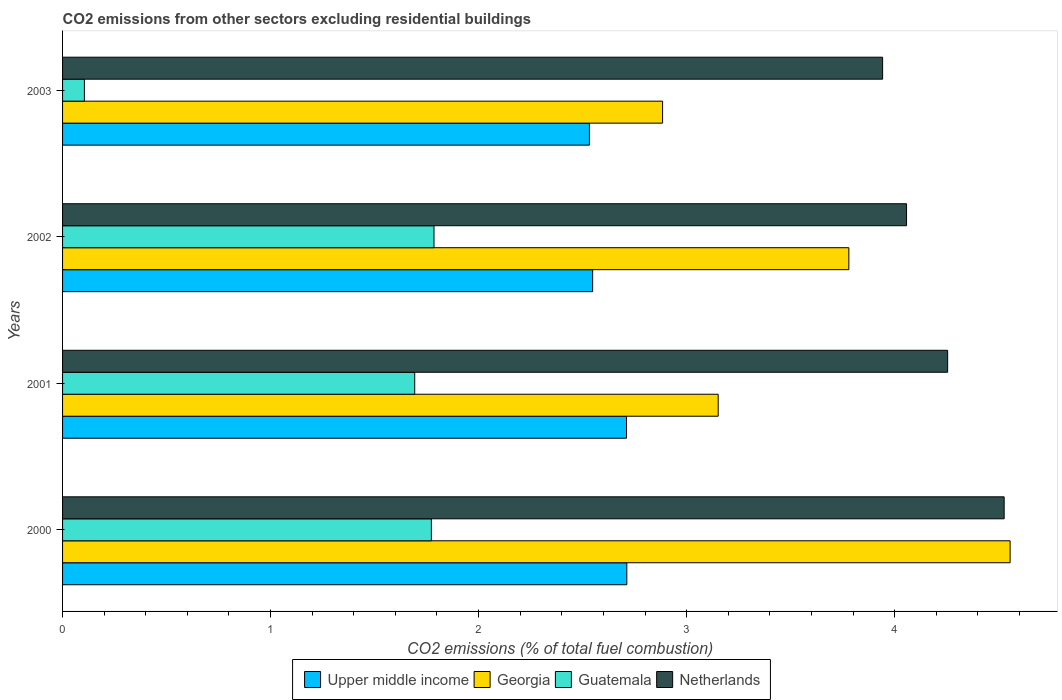How many different coloured bars are there?
Provide a short and direct response. 4. How many bars are there on the 1st tick from the top?
Your answer should be compact. 4. How many bars are there on the 1st tick from the bottom?
Offer a very short reply. 4. In how many cases, is the number of bars for a given year not equal to the number of legend labels?
Provide a short and direct response. 0. What is the total CO2 emitted in Netherlands in 2002?
Make the answer very short. 4.06. Across all years, what is the maximum total CO2 emitted in Upper middle income?
Your answer should be very brief. 2.71. Across all years, what is the minimum total CO2 emitted in Georgia?
Provide a short and direct response. 2.88. In which year was the total CO2 emitted in Netherlands maximum?
Your answer should be compact. 2000. What is the total total CO2 emitted in Georgia in the graph?
Provide a short and direct response. 14.37. What is the difference between the total CO2 emitted in Guatemala in 2000 and that in 2001?
Offer a very short reply. 0.08. What is the difference between the total CO2 emitted in Guatemala in 2000 and the total CO2 emitted in Upper middle income in 2003?
Provide a succinct answer. -0.76. What is the average total CO2 emitted in Georgia per year?
Your answer should be very brief. 3.59. In the year 2003, what is the difference between the total CO2 emitted in Upper middle income and total CO2 emitted in Netherlands?
Give a very brief answer. -1.41. What is the ratio of the total CO2 emitted in Upper middle income in 2001 to that in 2002?
Your answer should be compact. 1.06. Is the difference between the total CO2 emitted in Upper middle income in 2000 and 2003 greater than the difference between the total CO2 emitted in Netherlands in 2000 and 2003?
Your answer should be compact. No. What is the difference between the highest and the second highest total CO2 emitted in Netherlands?
Your answer should be very brief. 0.27. What is the difference between the highest and the lowest total CO2 emitted in Netherlands?
Provide a short and direct response. 0.58. Is the sum of the total CO2 emitted in Netherlands in 2001 and 2002 greater than the maximum total CO2 emitted in Guatemala across all years?
Ensure brevity in your answer.  Yes. What does the 2nd bar from the top in 2002 represents?
Your answer should be very brief. Guatemala. What does the 1st bar from the bottom in 2002 represents?
Give a very brief answer. Upper middle income. Are all the bars in the graph horizontal?
Keep it short and to the point. Yes. What is the difference between two consecutive major ticks on the X-axis?
Provide a succinct answer. 1. Does the graph contain grids?
Keep it short and to the point. No. How many legend labels are there?
Offer a very short reply. 4. What is the title of the graph?
Your answer should be compact. CO2 emissions from other sectors excluding residential buildings. What is the label or title of the X-axis?
Provide a short and direct response. CO2 emissions (% of total fuel combustion). What is the label or title of the Y-axis?
Make the answer very short. Years. What is the CO2 emissions (% of total fuel combustion) in Upper middle income in 2000?
Provide a succinct answer. 2.71. What is the CO2 emissions (% of total fuel combustion) of Georgia in 2000?
Offer a very short reply. 4.56. What is the CO2 emissions (% of total fuel combustion) in Guatemala in 2000?
Provide a short and direct response. 1.77. What is the CO2 emissions (% of total fuel combustion) in Netherlands in 2000?
Your response must be concise. 4.53. What is the CO2 emissions (% of total fuel combustion) in Upper middle income in 2001?
Provide a succinct answer. 2.71. What is the CO2 emissions (% of total fuel combustion) of Georgia in 2001?
Your answer should be compact. 3.15. What is the CO2 emissions (% of total fuel combustion) in Guatemala in 2001?
Make the answer very short. 1.69. What is the CO2 emissions (% of total fuel combustion) of Netherlands in 2001?
Your answer should be very brief. 4.25. What is the CO2 emissions (% of total fuel combustion) in Upper middle income in 2002?
Your response must be concise. 2.55. What is the CO2 emissions (% of total fuel combustion) of Georgia in 2002?
Your answer should be compact. 3.78. What is the CO2 emissions (% of total fuel combustion) in Guatemala in 2002?
Make the answer very short. 1.79. What is the CO2 emissions (% of total fuel combustion) of Netherlands in 2002?
Make the answer very short. 4.06. What is the CO2 emissions (% of total fuel combustion) of Upper middle income in 2003?
Your response must be concise. 2.53. What is the CO2 emissions (% of total fuel combustion) of Georgia in 2003?
Offer a terse response. 2.88. What is the CO2 emissions (% of total fuel combustion) in Guatemala in 2003?
Provide a short and direct response. 0.1. What is the CO2 emissions (% of total fuel combustion) in Netherlands in 2003?
Provide a succinct answer. 3.94. Across all years, what is the maximum CO2 emissions (% of total fuel combustion) of Upper middle income?
Offer a terse response. 2.71. Across all years, what is the maximum CO2 emissions (% of total fuel combustion) of Georgia?
Give a very brief answer. 4.56. Across all years, what is the maximum CO2 emissions (% of total fuel combustion) in Guatemala?
Your response must be concise. 1.79. Across all years, what is the maximum CO2 emissions (% of total fuel combustion) of Netherlands?
Give a very brief answer. 4.53. Across all years, what is the minimum CO2 emissions (% of total fuel combustion) of Upper middle income?
Keep it short and to the point. 2.53. Across all years, what is the minimum CO2 emissions (% of total fuel combustion) in Georgia?
Make the answer very short. 2.88. Across all years, what is the minimum CO2 emissions (% of total fuel combustion) in Guatemala?
Offer a terse response. 0.1. Across all years, what is the minimum CO2 emissions (% of total fuel combustion) of Netherlands?
Give a very brief answer. 3.94. What is the total CO2 emissions (% of total fuel combustion) of Upper middle income in the graph?
Ensure brevity in your answer.  10.51. What is the total CO2 emissions (% of total fuel combustion) of Georgia in the graph?
Provide a short and direct response. 14.37. What is the total CO2 emissions (% of total fuel combustion) in Guatemala in the graph?
Keep it short and to the point. 5.36. What is the total CO2 emissions (% of total fuel combustion) in Netherlands in the graph?
Your answer should be compact. 16.78. What is the difference between the CO2 emissions (% of total fuel combustion) in Upper middle income in 2000 and that in 2001?
Your response must be concise. 0. What is the difference between the CO2 emissions (% of total fuel combustion) in Georgia in 2000 and that in 2001?
Provide a short and direct response. 1.4. What is the difference between the CO2 emissions (% of total fuel combustion) in Netherlands in 2000 and that in 2001?
Give a very brief answer. 0.27. What is the difference between the CO2 emissions (% of total fuel combustion) in Upper middle income in 2000 and that in 2002?
Your answer should be compact. 0.16. What is the difference between the CO2 emissions (% of total fuel combustion) in Georgia in 2000 and that in 2002?
Keep it short and to the point. 0.78. What is the difference between the CO2 emissions (% of total fuel combustion) in Guatemala in 2000 and that in 2002?
Ensure brevity in your answer.  -0.01. What is the difference between the CO2 emissions (% of total fuel combustion) of Netherlands in 2000 and that in 2002?
Keep it short and to the point. 0.47. What is the difference between the CO2 emissions (% of total fuel combustion) in Upper middle income in 2000 and that in 2003?
Your answer should be compact. 0.18. What is the difference between the CO2 emissions (% of total fuel combustion) of Georgia in 2000 and that in 2003?
Keep it short and to the point. 1.67. What is the difference between the CO2 emissions (% of total fuel combustion) in Guatemala in 2000 and that in 2003?
Give a very brief answer. 1.67. What is the difference between the CO2 emissions (% of total fuel combustion) of Netherlands in 2000 and that in 2003?
Keep it short and to the point. 0.58. What is the difference between the CO2 emissions (% of total fuel combustion) in Upper middle income in 2001 and that in 2002?
Keep it short and to the point. 0.16. What is the difference between the CO2 emissions (% of total fuel combustion) of Georgia in 2001 and that in 2002?
Offer a very short reply. -0.63. What is the difference between the CO2 emissions (% of total fuel combustion) in Guatemala in 2001 and that in 2002?
Give a very brief answer. -0.09. What is the difference between the CO2 emissions (% of total fuel combustion) of Netherlands in 2001 and that in 2002?
Offer a terse response. 0.2. What is the difference between the CO2 emissions (% of total fuel combustion) in Upper middle income in 2001 and that in 2003?
Give a very brief answer. 0.18. What is the difference between the CO2 emissions (% of total fuel combustion) of Georgia in 2001 and that in 2003?
Your answer should be compact. 0.27. What is the difference between the CO2 emissions (% of total fuel combustion) of Guatemala in 2001 and that in 2003?
Your answer should be very brief. 1.59. What is the difference between the CO2 emissions (% of total fuel combustion) in Netherlands in 2001 and that in 2003?
Provide a succinct answer. 0.31. What is the difference between the CO2 emissions (% of total fuel combustion) in Upper middle income in 2002 and that in 2003?
Provide a short and direct response. 0.02. What is the difference between the CO2 emissions (% of total fuel combustion) in Georgia in 2002 and that in 2003?
Your response must be concise. 0.9. What is the difference between the CO2 emissions (% of total fuel combustion) in Guatemala in 2002 and that in 2003?
Your response must be concise. 1.68. What is the difference between the CO2 emissions (% of total fuel combustion) in Netherlands in 2002 and that in 2003?
Offer a very short reply. 0.12. What is the difference between the CO2 emissions (% of total fuel combustion) in Upper middle income in 2000 and the CO2 emissions (% of total fuel combustion) in Georgia in 2001?
Provide a succinct answer. -0.44. What is the difference between the CO2 emissions (% of total fuel combustion) of Upper middle income in 2000 and the CO2 emissions (% of total fuel combustion) of Guatemala in 2001?
Keep it short and to the point. 1.02. What is the difference between the CO2 emissions (% of total fuel combustion) of Upper middle income in 2000 and the CO2 emissions (% of total fuel combustion) of Netherlands in 2001?
Make the answer very short. -1.54. What is the difference between the CO2 emissions (% of total fuel combustion) of Georgia in 2000 and the CO2 emissions (% of total fuel combustion) of Guatemala in 2001?
Offer a very short reply. 2.86. What is the difference between the CO2 emissions (% of total fuel combustion) of Georgia in 2000 and the CO2 emissions (% of total fuel combustion) of Netherlands in 2001?
Make the answer very short. 0.3. What is the difference between the CO2 emissions (% of total fuel combustion) in Guatemala in 2000 and the CO2 emissions (% of total fuel combustion) in Netherlands in 2001?
Your answer should be very brief. -2.48. What is the difference between the CO2 emissions (% of total fuel combustion) of Upper middle income in 2000 and the CO2 emissions (% of total fuel combustion) of Georgia in 2002?
Offer a very short reply. -1.07. What is the difference between the CO2 emissions (% of total fuel combustion) of Upper middle income in 2000 and the CO2 emissions (% of total fuel combustion) of Guatemala in 2002?
Keep it short and to the point. 0.93. What is the difference between the CO2 emissions (% of total fuel combustion) of Upper middle income in 2000 and the CO2 emissions (% of total fuel combustion) of Netherlands in 2002?
Provide a short and direct response. -1.34. What is the difference between the CO2 emissions (% of total fuel combustion) of Georgia in 2000 and the CO2 emissions (% of total fuel combustion) of Guatemala in 2002?
Give a very brief answer. 2.77. What is the difference between the CO2 emissions (% of total fuel combustion) in Georgia in 2000 and the CO2 emissions (% of total fuel combustion) in Netherlands in 2002?
Your answer should be compact. 0.5. What is the difference between the CO2 emissions (% of total fuel combustion) of Guatemala in 2000 and the CO2 emissions (% of total fuel combustion) of Netherlands in 2002?
Provide a succinct answer. -2.28. What is the difference between the CO2 emissions (% of total fuel combustion) in Upper middle income in 2000 and the CO2 emissions (% of total fuel combustion) in Georgia in 2003?
Provide a short and direct response. -0.17. What is the difference between the CO2 emissions (% of total fuel combustion) of Upper middle income in 2000 and the CO2 emissions (% of total fuel combustion) of Guatemala in 2003?
Your response must be concise. 2.61. What is the difference between the CO2 emissions (% of total fuel combustion) in Upper middle income in 2000 and the CO2 emissions (% of total fuel combustion) in Netherlands in 2003?
Your answer should be very brief. -1.23. What is the difference between the CO2 emissions (% of total fuel combustion) of Georgia in 2000 and the CO2 emissions (% of total fuel combustion) of Guatemala in 2003?
Provide a succinct answer. 4.45. What is the difference between the CO2 emissions (% of total fuel combustion) of Georgia in 2000 and the CO2 emissions (% of total fuel combustion) of Netherlands in 2003?
Your response must be concise. 0.61. What is the difference between the CO2 emissions (% of total fuel combustion) in Guatemala in 2000 and the CO2 emissions (% of total fuel combustion) in Netherlands in 2003?
Your response must be concise. -2.17. What is the difference between the CO2 emissions (% of total fuel combustion) in Upper middle income in 2001 and the CO2 emissions (% of total fuel combustion) in Georgia in 2002?
Your answer should be compact. -1.07. What is the difference between the CO2 emissions (% of total fuel combustion) in Upper middle income in 2001 and the CO2 emissions (% of total fuel combustion) in Guatemala in 2002?
Offer a very short reply. 0.93. What is the difference between the CO2 emissions (% of total fuel combustion) of Upper middle income in 2001 and the CO2 emissions (% of total fuel combustion) of Netherlands in 2002?
Offer a very short reply. -1.35. What is the difference between the CO2 emissions (% of total fuel combustion) of Georgia in 2001 and the CO2 emissions (% of total fuel combustion) of Guatemala in 2002?
Offer a very short reply. 1.37. What is the difference between the CO2 emissions (% of total fuel combustion) of Georgia in 2001 and the CO2 emissions (% of total fuel combustion) of Netherlands in 2002?
Make the answer very short. -0.91. What is the difference between the CO2 emissions (% of total fuel combustion) in Guatemala in 2001 and the CO2 emissions (% of total fuel combustion) in Netherlands in 2002?
Make the answer very short. -2.36. What is the difference between the CO2 emissions (% of total fuel combustion) of Upper middle income in 2001 and the CO2 emissions (% of total fuel combustion) of Georgia in 2003?
Your answer should be compact. -0.17. What is the difference between the CO2 emissions (% of total fuel combustion) of Upper middle income in 2001 and the CO2 emissions (% of total fuel combustion) of Guatemala in 2003?
Provide a succinct answer. 2.61. What is the difference between the CO2 emissions (% of total fuel combustion) in Upper middle income in 2001 and the CO2 emissions (% of total fuel combustion) in Netherlands in 2003?
Ensure brevity in your answer.  -1.23. What is the difference between the CO2 emissions (% of total fuel combustion) in Georgia in 2001 and the CO2 emissions (% of total fuel combustion) in Guatemala in 2003?
Your response must be concise. 3.05. What is the difference between the CO2 emissions (% of total fuel combustion) of Georgia in 2001 and the CO2 emissions (% of total fuel combustion) of Netherlands in 2003?
Offer a very short reply. -0.79. What is the difference between the CO2 emissions (% of total fuel combustion) in Guatemala in 2001 and the CO2 emissions (% of total fuel combustion) in Netherlands in 2003?
Keep it short and to the point. -2.25. What is the difference between the CO2 emissions (% of total fuel combustion) in Upper middle income in 2002 and the CO2 emissions (% of total fuel combustion) in Georgia in 2003?
Offer a very short reply. -0.34. What is the difference between the CO2 emissions (% of total fuel combustion) in Upper middle income in 2002 and the CO2 emissions (% of total fuel combustion) in Guatemala in 2003?
Make the answer very short. 2.44. What is the difference between the CO2 emissions (% of total fuel combustion) of Upper middle income in 2002 and the CO2 emissions (% of total fuel combustion) of Netherlands in 2003?
Your response must be concise. -1.39. What is the difference between the CO2 emissions (% of total fuel combustion) in Georgia in 2002 and the CO2 emissions (% of total fuel combustion) in Guatemala in 2003?
Offer a terse response. 3.68. What is the difference between the CO2 emissions (% of total fuel combustion) of Georgia in 2002 and the CO2 emissions (% of total fuel combustion) of Netherlands in 2003?
Offer a very short reply. -0.16. What is the difference between the CO2 emissions (% of total fuel combustion) in Guatemala in 2002 and the CO2 emissions (% of total fuel combustion) in Netherlands in 2003?
Provide a short and direct response. -2.16. What is the average CO2 emissions (% of total fuel combustion) of Upper middle income per year?
Provide a succinct answer. 2.63. What is the average CO2 emissions (% of total fuel combustion) in Georgia per year?
Offer a very short reply. 3.59. What is the average CO2 emissions (% of total fuel combustion) of Guatemala per year?
Your answer should be compact. 1.34. What is the average CO2 emissions (% of total fuel combustion) of Netherlands per year?
Ensure brevity in your answer.  4.2. In the year 2000, what is the difference between the CO2 emissions (% of total fuel combustion) in Upper middle income and CO2 emissions (% of total fuel combustion) in Georgia?
Provide a short and direct response. -1.84. In the year 2000, what is the difference between the CO2 emissions (% of total fuel combustion) in Upper middle income and CO2 emissions (% of total fuel combustion) in Guatemala?
Ensure brevity in your answer.  0.94. In the year 2000, what is the difference between the CO2 emissions (% of total fuel combustion) of Upper middle income and CO2 emissions (% of total fuel combustion) of Netherlands?
Make the answer very short. -1.81. In the year 2000, what is the difference between the CO2 emissions (% of total fuel combustion) of Georgia and CO2 emissions (% of total fuel combustion) of Guatemala?
Ensure brevity in your answer.  2.78. In the year 2000, what is the difference between the CO2 emissions (% of total fuel combustion) of Georgia and CO2 emissions (% of total fuel combustion) of Netherlands?
Give a very brief answer. 0.03. In the year 2000, what is the difference between the CO2 emissions (% of total fuel combustion) in Guatemala and CO2 emissions (% of total fuel combustion) in Netherlands?
Provide a succinct answer. -2.75. In the year 2001, what is the difference between the CO2 emissions (% of total fuel combustion) of Upper middle income and CO2 emissions (% of total fuel combustion) of Georgia?
Offer a terse response. -0.44. In the year 2001, what is the difference between the CO2 emissions (% of total fuel combustion) of Upper middle income and CO2 emissions (% of total fuel combustion) of Guatemala?
Give a very brief answer. 1.02. In the year 2001, what is the difference between the CO2 emissions (% of total fuel combustion) in Upper middle income and CO2 emissions (% of total fuel combustion) in Netherlands?
Give a very brief answer. -1.54. In the year 2001, what is the difference between the CO2 emissions (% of total fuel combustion) of Georgia and CO2 emissions (% of total fuel combustion) of Guatemala?
Your answer should be compact. 1.46. In the year 2001, what is the difference between the CO2 emissions (% of total fuel combustion) in Georgia and CO2 emissions (% of total fuel combustion) in Netherlands?
Make the answer very short. -1.1. In the year 2001, what is the difference between the CO2 emissions (% of total fuel combustion) of Guatemala and CO2 emissions (% of total fuel combustion) of Netherlands?
Provide a succinct answer. -2.56. In the year 2002, what is the difference between the CO2 emissions (% of total fuel combustion) of Upper middle income and CO2 emissions (% of total fuel combustion) of Georgia?
Your answer should be very brief. -1.23. In the year 2002, what is the difference between the CO2 emissions (% of total fuel combustion) of Upper middle income and CO2 emissions (% of total fuel combustion) of Guatemala?
Make the answer very short. 0.76. In the year 2002, what is the difference between the CO2 emissions (% of total fuel combustion) in Upper middle income and CO2 emissions (% of total fuel combustion) in Netherlands?
Ensure brevity in your answer.  -1.51. In the year 2002, what is the difference between the CO2 emissions (% of total fuel combustion) in Georgia and CO2 emissions (% of total fuel combustion) in Guatemala?
Ensure brevity in your answer.  1.99. In the year 2002, what is the difference between the CO2 emissions (% of total fuel combustion) of Georgia and CO2 emissions (% of total fuel combustion) of Netherlands?
Give a very brief answer. -0.28. In the year 2002, what is the difference between the CO2 emissions (% of total fuel combustion) in Guatemala and CO2 emissions (% of total fuel combustion) in Netherlands?
Provide a succinct answer. -2.27. In the year 2003, what is the difference between the CO2 emissions (% of total fuel combustion) in Upper middle income and CO2 emissions (% of total fuel combustion) in Georgia?
Your response must be concise. -0.35. In the year 2003, what is the difference between the CO2 emissions (% of total fuel combustion) in Upper middle income and CO2 emissions (% of total fuel combustion) in Guatemala?
Provide a short and direct response. 2.43. In the year 2003, what is the difference between the CO2 emissions (% of total fuel combustion) of Upper middle income and CO2 emissions (% of total fuel combustion) of Netherlands?
Your answer should be very brief. -1.41. In the year 2003, what is the difference between the CO2 emissions (% of total fuel combustion) of Georgia and CO2 emissions (% of total fuel combustion) of Guatemala?
Your answer should be very brief. 2.78. In the year 2003, what is the difference between the CO2 emissions (% of total fuel combustion) in Georgia and CO2 emissions (% of total fuel combustion) in Netherlands?
Your answer should be compact. -1.06. In the year 2003, what is the difference between the CO2 emissions (% of total fuel combustion) of Guatemala and CO2 emissions (% of total fuel combustion) of Netherlands?
Keep it short and to the point. -3.84. What is the ratio of the CO2 emissions (% of total fuel combustion) of Georgia in 2000 to that in 2001?
Your answer should be very brief. 1.45. What is the ratio of the CO2 emissions (% of total fuel combustion) in Guatemala in 2000 to that in 2001?
Offer a terse response. 1.05. What is the ratio of the CO2 emissions (% of total fuel combustion) of Netherlands in 2000 to that in 2001?
Offer a very short reply. 1.06. What is the ratio of the CO2 emissions (% of total fuel combustion) in Upper middle income in 2000 to that in 2002?
Your answer should be compact. 1.06. What is the ratio of the CO2 emissions (% of total fuel combustion) in Georgia in 2000 to that in 2002?
Make the answer very short. 1.21. What is the ratio of the CO2 emissions (% of total fuel combustion) in Guatemala in 2000 to that in 2002?
Provide a succinct answer. 0.99. What is the ratio of the CO2 emissions (% of total fuel combustion) in Netherlands in 2000 to that in 2002?
Provide a short and direct response. 1.12. What is the ratio of the CO2 emissions (% of total fuel combustion) in Upper middle income in 2000 to that in 2003?
Keep it short and to the point. 1.07. What is the ratio of the CO2 emissions (% of total fuel combustion) in Georgia in 2000 to that in 2003?
Offer a terse response. 1.58. What is the ratio of the CO2 emissions (% of total fuel combustion) in Guatemala in 2000 to that in 2003?
Ensure brevity in your answer.  16.9. What is the ratio of the CO2 emissions (% of total fuel combustion) of Netherlands in 2000 to that in 2003?
Provide a succinct answer. 1.15. What is the ratio of the CO2 emissions (% of total fuel combustion) of Upper middle income in 2001 to that in 2002?
Provide a succinct answer. 1.06. What is the ratio of the CO2 emissions (% of total fuel combustion) in Georgia in 2001 to that in 2002?
Offer a very short reply. 0.83. What is the ratio of the CO2 emissions (% of total fuel combustion) in Guatemala in 2001 to that in 2002?
Ensure brevity in your answer.  0.95. What is the ratio of the CO2 emissions (% of total fuel combustion) of Netherlands in 2001 to that in 2002?
Give a very brief answer. 1.05. What is the ratio of the CO2 emissions (% of total fuel combustion) in Upper middle income in 2001 to that in 2003?
Keep it short and to the point. 1.07. What is the ratio of the CO2 emissions (% of total fuel combustion) of Georgia in 2001 to that in 2003?
Provide a succinct answer. 1.09. What is the ratio of the CO2 emissions (% of total fuel combustion) of Guatemala in 2001 to that in 2003?
Offer a very short reply. 16.13. What is the ratio of the CO2 emissions (% of total fuel combustion) of Netherlands in 2001 to that in 2003?
Offer a terse response. 1.08. What is the ratio of the CO2 emissions (% of total fuel combustion) of Georgia in 2002 to that in 2003?
Offer a very short reply. 1.31. What is the ratio of the CO2 emissions (% of total fuel combustion) in Guatemala in 2002 to that in 2003?
Provide a succinct answer. 17.02. What is the ratio of the CO2 emissions (% of total fuel combustion) of Netherlands in 2002 to that in 2003?
Ensure brevity in your answer.  1.03. What is the difference between the highest and the second highest CO2 emissions (% of total fuel combustion) in Upper middle income?
Your response must be concise. 0. What is the difference between the highest and the second highest CO2 emissions (% of total fuel combustion) of Georgia?
Provide a short and direct response. 0.78. What is the difference between the highest and the second highest CO2 emissions (% of total fuel combustion) of Guatemala?
Your answer should be very brief. 0.01. What is the difference between the highest and the second highest CO2 emissions (% of total fuel combustion) in Netherlands?
Offer a terse response. 0.27. What is the difference between the highest and the lowest CO2 emissions (% of total fuel combustion) of Upper middle income?
Keep it short and to the point. 0.18. What is the difference between the highest and the lowest CO2 emissions (% of total fuel combustion) of Georgia?
Ensure brevity in your answer.  1.67. What is the difference between the highest and the lowest CO2 emissions (% of total fuel combustion) in Guatemala?
Make the answer very short. 1.68. What is the difference between the highest and the lowest CO2 emissions (% of total fuel combustion) in Netherlands?
Give a very brief answer. 0.58. 